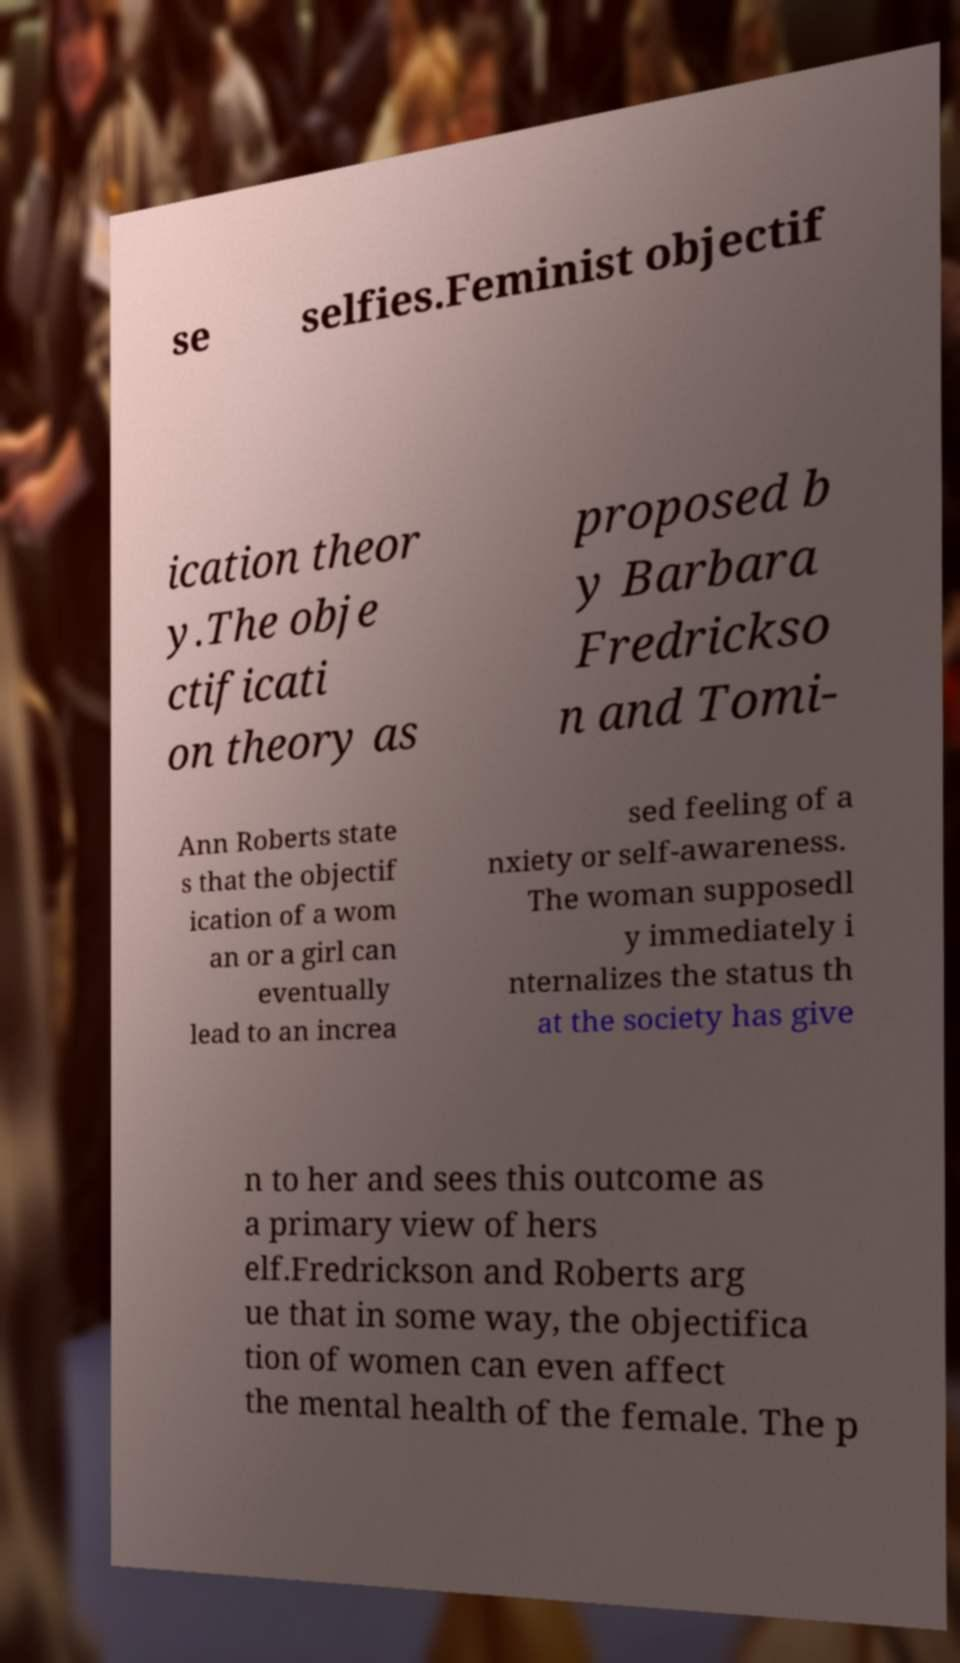Can you accurately transcribe the text from the provided image for me? se selfies.Feminist objectif ication theor y.The obje ctificati on theory as proposed b y Barbara Fredrickso n and Tomi- Ann Roberts state s that the objectif ication of a wom an or a girl can eventually lead to an increa sed feeling of a nxiety or self-awareness. The woman supposedl y immediately i nternalizes the status th at the society has give n to her and sees this outcome as a primary view of hers elf.Fredrickson and Roberts arg ue that in some way, the objectifica tion of women can even affect the mental health of the female. The p 